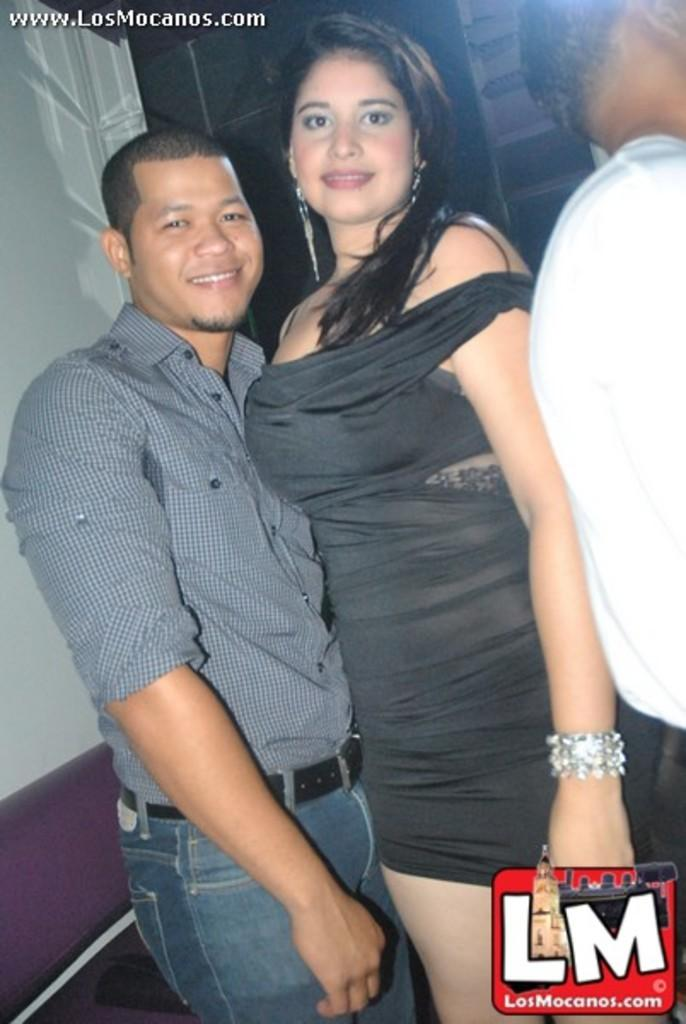How many people are in the image? There are three people in the image. What are the people in the image doing? The two persons are standing and smiling, while the third person is also present. What can be seen in the background of the image? There are items visible in the background of the image. Can you describe any imperfections or marks on the image? Yes, there are watermarks on the image. What type of line is being used by the person in the image? There is no line or any activity involving a line present in the image. What kind of needlework is the person in the image engaged in? There is no needle or needlework activity depicted in the image. 